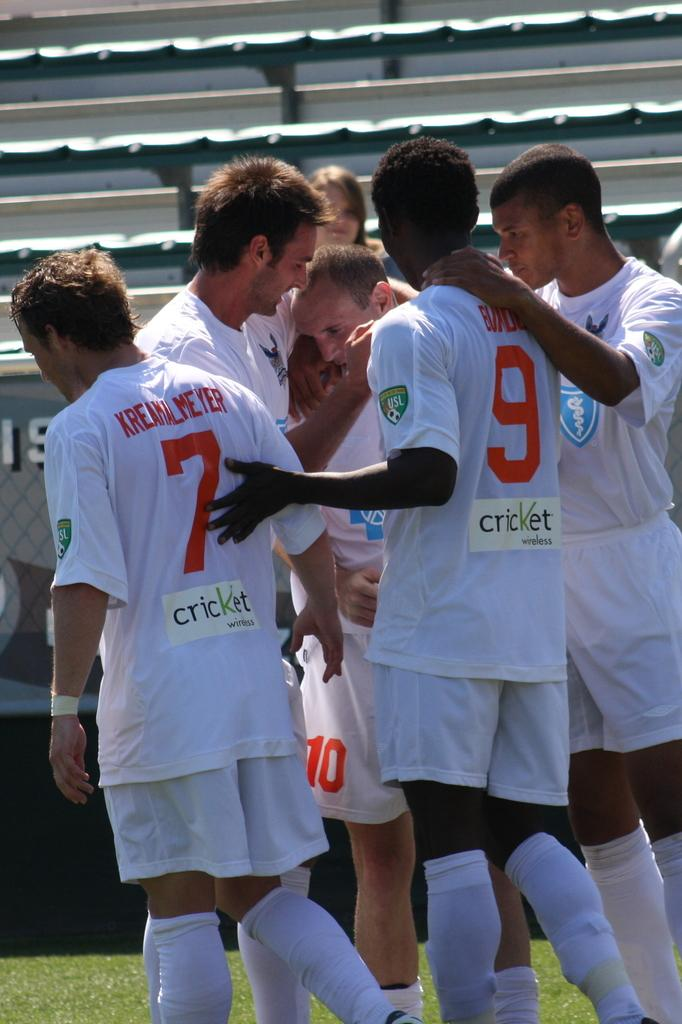What is the main subject of the image? The main subject of the image is a group of people. What are the people in the image doing? The people are standing. What are the people wearing in the image? The people are wearing white-colored dresses. Where is the group of people located in the image? The group of people is in the middle of the image. What can be seen in the background of the image? There is a seating area in the background of the image. What is the reason behind the people holding money in the image? There is no indication in the image that the people are holding money, so it cannot be determined from the picture. 